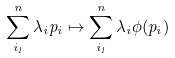<formula> <loc_0><loc_0><loc_500><loc_500>\sum _ { i _ { 1 } } ^ { n } \lambda _ { i } p _ { i } \mapsto \sum _ { i _ { 1 } } ^ { n } \lambda _ { i } \phi ( p _ { i } )</formula> 